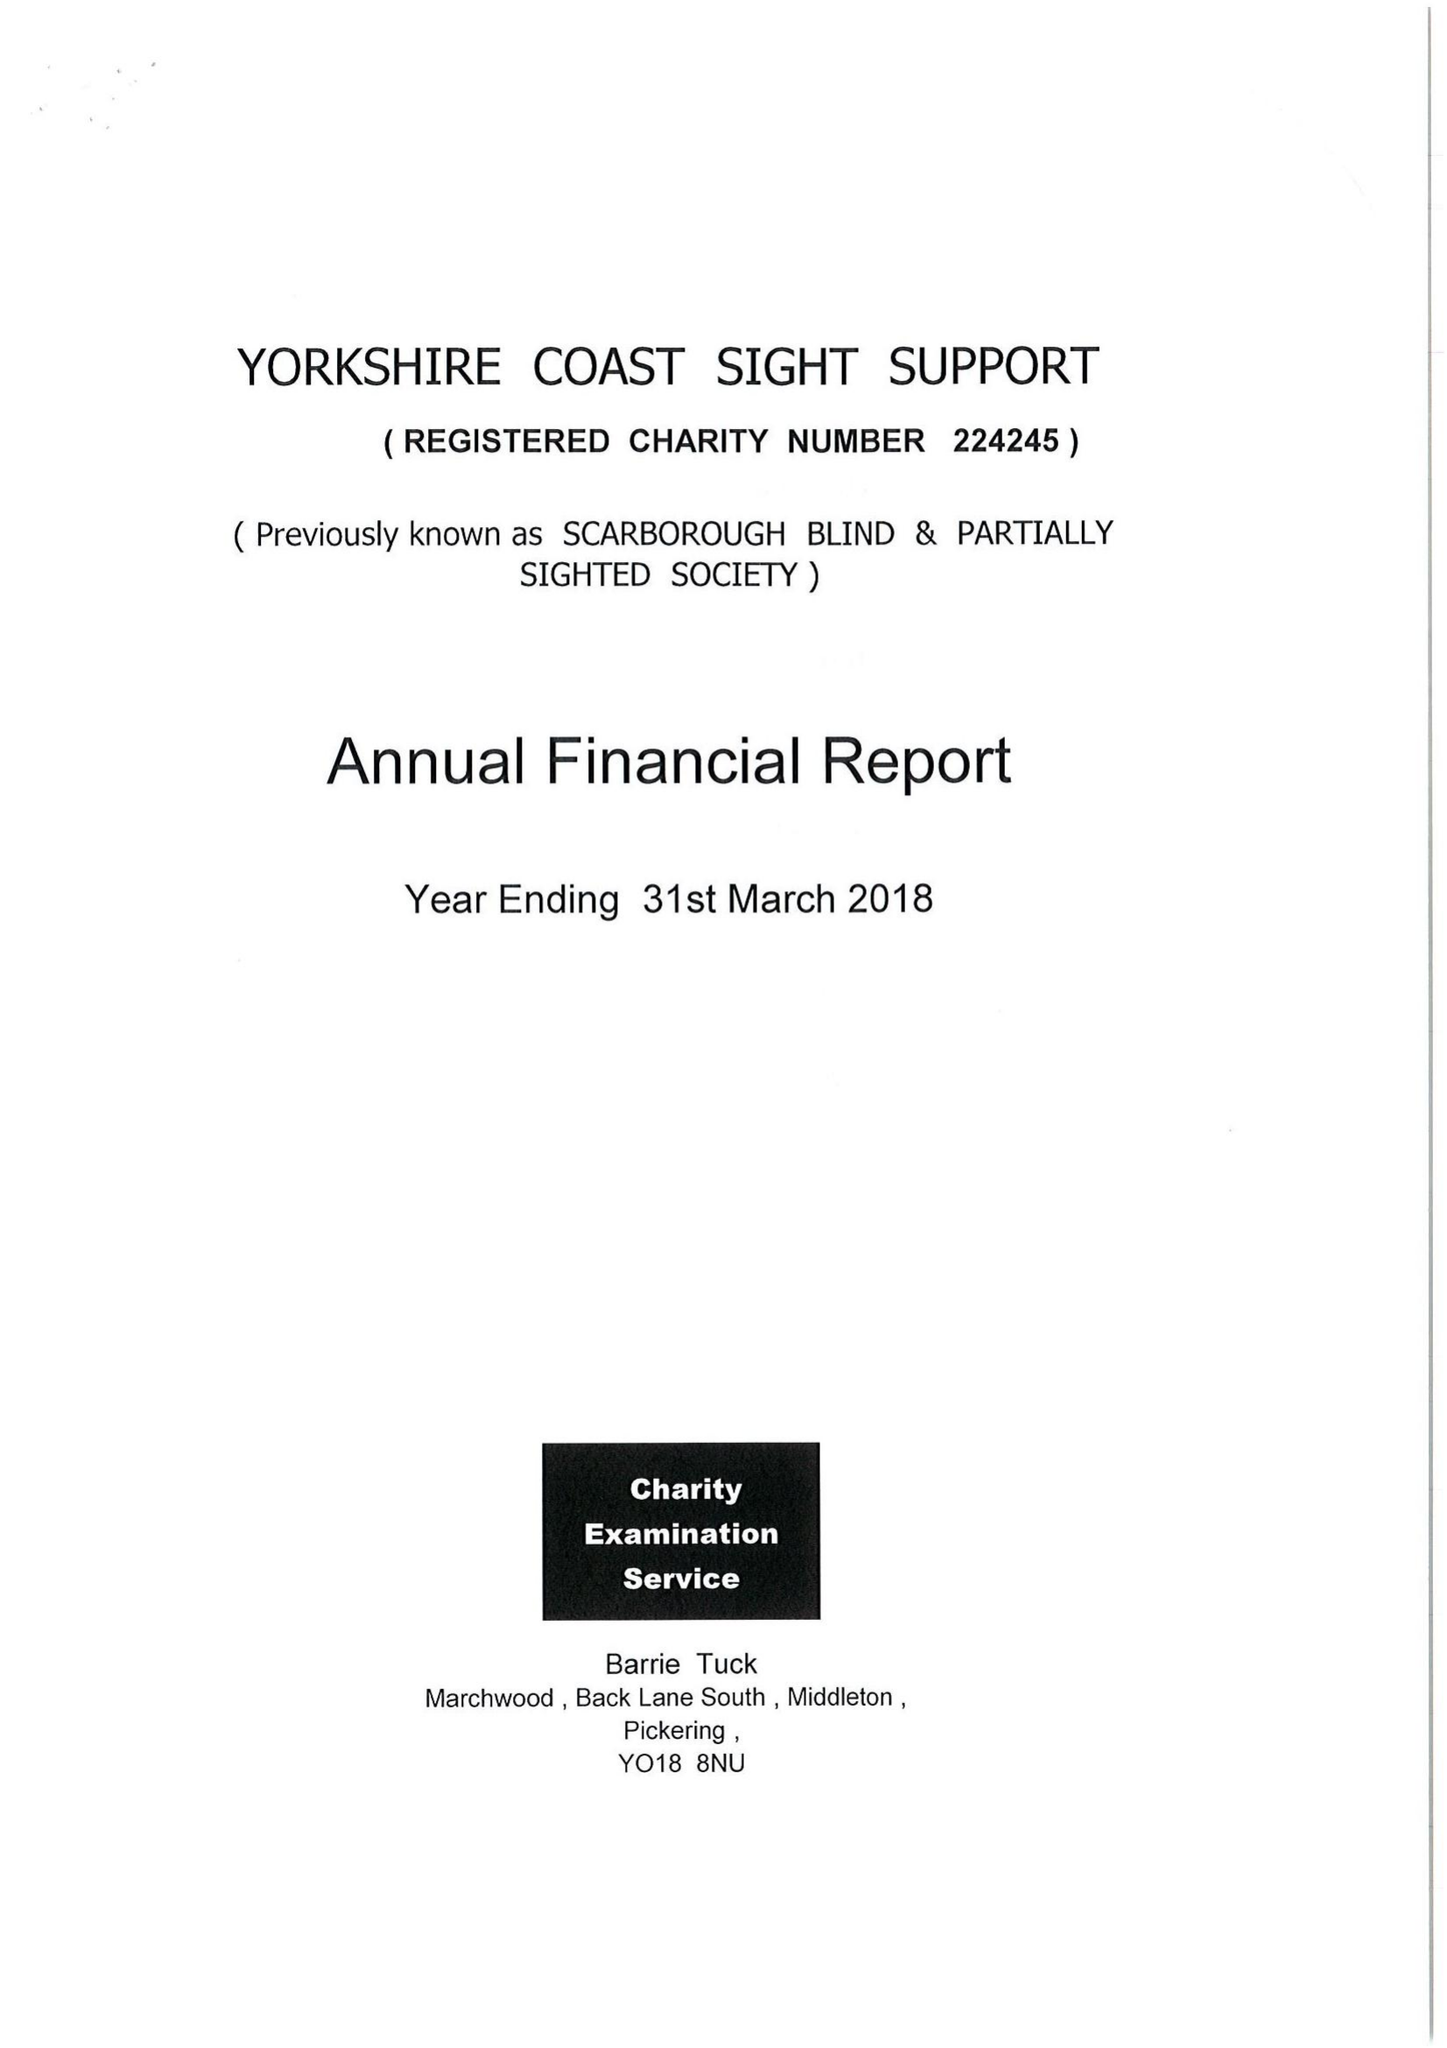What is the value for the spending_annually_in_british_pounds?
Answer the question using a single word or phrase. 87246.00 